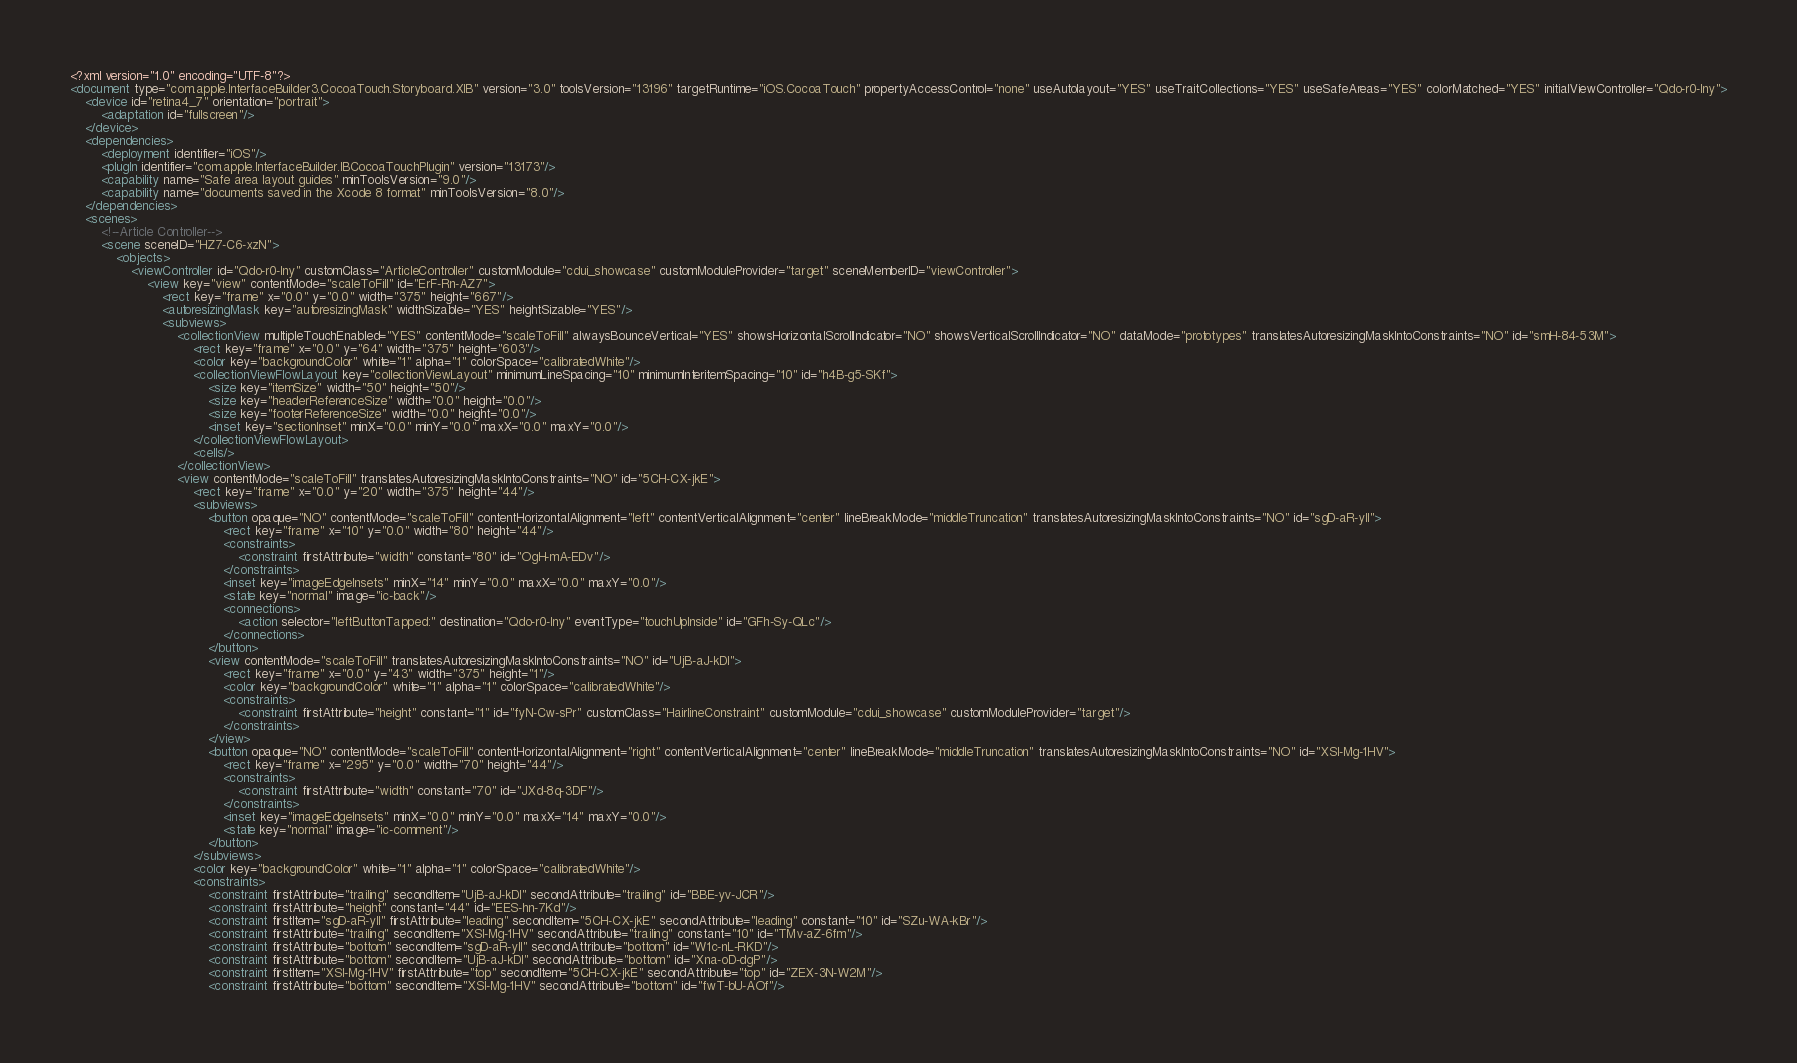Convert code to text. <code><loc_0><loc_0><loc_500><loc_500><_XML_><?xml version="1.0" encoding="UTF-8"?>
<document type="com.apple.InterfaceBuilder3.CocoaTouch.Storyboard.XIB" version="3.0" toolsVersion="13196" targetRuntime="iOS.CocoaTouch" propertyAccessControl="none" useAutolayout="YES" useTraitCollections="YES" useSafeAreas="YES" colorMatched="YES" initialViewController="Qdo-r0-Iny">
    <device id="retina4_7" orientation="portrait">
        <adaptation id="fullscreen"/>
    </device>
    <dependencies>
        <deployment identifier="iOS"/>
        <plugIn identifier="com.apple.InterfaceBuilder.IBCocoaTouchPlugin" version="13173"/>
        <capability name="Safe area layout guides" minToolsVersion="9.0"/>
        <capability name="documents saved in the Xcode 8 format" minToolsVersion="8.0"/>
    </dependencies>
    <scenes>
        <!--Article Controller-->
        <scene sceneID="HZ7-C6-xzN">
            <objects>
                <viewController id="Qdo-r0-Iny" customClass="ArticleController" customModule="cdui_showcase" customModuleProvider="target" sceneMemberID="viewController">
                    <view key="view" contentMode="scaleToFill" id="ErF-Rn-AZ7">
                        <rect key="frame" x="0.0" y="0.0" width="375" height="667"/>
                        <autoresizingMask key="autoresizingMask" widthSizable="YES" heightSizable="YES"/>
                        <subviews>
                            <collectionView multipleTouchEnabled="YES" contentMode="scaleToFill" alwaysBounceVertical="YES" showsHorizontalScrollIndicator="NO" showsVerticalScrollIndicator="NO" dataMode="prototypes" translatesAutoresizingMaskIntoConstraints="NO" id="smH-84-53M">
                                <rect key="frame" x="0.0" y="64" width="375" height="603"/>
                                <color key="backgroundColor" white="1" alpha="1" colorSpace="calibratedWhite"/>
                                <collectionViewFlowLayout key="collectionViewLayout" minimumLineSpacing="10" minimumInteritemSpacing="10" id="h4B-g5-SKf">
                                    <size key="itemSize" width="50" height="50"/>
                                    <size key="headerReferenceSize" width="0.0" height="0.0"/>
                                    <size key="footerReferenceSize" width="0.0" height="0.0"/>
                                    <inset key="sectionInset" minX="0.0" minY="0.0" maxX="0.0" maxY="0.0"/>
                                </collectionViewFlowLayout>
                                <cells/>
                            </collectionView>
                            <view contentMode="scaleToFill" translatesAutoresizingMaskIntoConstraints="NO" id="5CH-CX-jkE">
                                <rect key="frame" x="0.0" y="20" width="375" height="44"/>
                                <subviews>
                                    <button opaque="NO" contentMode="scaleToFill" contentHorizontalAlignment="left" contentVerticalAlignment="center" lineBreakMode="middleTruncation" translatesAutoresizingMaskIntoConstraints="NO" id="sgD-aR-yll">
                                        <rect key="frame" x="10" y="0.0" width="80" height="44"/>
                                        <constraints>
                                            <constraint firstAttribute="width" constant="80" id="OgH-mA-EDv"/>
                                        </constraints>
                                        <inset key="imageEdgeInsets" minX="14" minY="0.0" maxX="0.0" maxY="0.0"/>
                                        <state key="normal" image="ic-back"/>
                                        <connections>
                                            <action selector="leftButtonTapped:" destination="Qdo-r0-Iny" eventType="touchUpInside" id="GFh-Sy-QLc"/>
                                        </connections>
                                    </button>
                                    <view contentMode="scaleToFill" translatesAutoresizingMaskIntoConstraints="NO" id="UjB-aJ-kDI">
                                        <rect key="frame" x="0.0" y="43" width="375" height="1"/>
                                        <color key="backgroundColor" white="1" alpha="1" colorSpace="calibratedWhite"/>
                                        <constraints>
                                            <constraint firstAttribute="height" constant="1" id="fyN-Cw-sPr" customClass="HairlineConstraint" customModule="cdui_showcase" customModuleProvider="target"/>
                                        </constraints>
                                    </view>
                                    <button opaque="NO" contentMode="scaleToFill" contentHorizontalAlignment="right" contentVerticalAlignment="center" lineBreakMode="middleTruncation" translatesAutoresizingMaskIntoConstraints="NO" id="XSl-Mg-1HV">
                                        <rect key="frame" x="295" y="0.0" width="70" height="44"/>
                                        <constraints>
                                            <constraint firstAttribute="width" constant="70" id="JXd-8q-3DF"/>
                                        </constraints>
                                        <inset key="imageEdgeInsets" minX="0.0" minY="0.0" maxX="14" maxY="0.0"/>
                                        <state key="normal" image="ic-comment"/>
                                    </button>
                                </subviews>
                                <color key="backgroundColor" white="1" alpha="1" colorSpace="calibratedWhite"/>
                                <constraints>
                                    <constraint firstAttribute="trailing" secondItem="UjB-aJ-kDI" secondAttribute="trailing" id="BBE-yv-JCR"/>
                                    <constraint firstAttribute="height" constant="44" id="EES-hn-7Kd"/>
                                    <constraint firstItem="sgD-aR-yll" firstAttribute="leading" secondItem="5CH-CX-jkE" secondAttribute="leading" constant="10" id="SZu-WA-kBr"/>
                                    <constraint firstAttribute="trailing" secondItem="XSl-Mg-1HV" secondAttribute="trailing" constant="10" id="TMv-aZ-6fm"/>
                                    <constraint firstAttribute="bottom" secondItem="sgD-aR-yll" secondAttribute="bottom" id="W1c-nL-RKD"/>
                                    <constraint firstAttribute="bottom" secondItem="UjB-aJ-kDI" secondAttribute="bottom" id="Xna-oD-dgP"/>
                                    <constraint firstItem="XSl-Mg-1HV" firstAttribute="top" secondItem="5CH-CX-jkE" secondAttribute="top" id="ZEX-3N-W2M"/>
                                    <constraint firstAttribute="bottom" secondItem="XSl-Mg-1HV" secondAttribute="bottom" id="fwT-bU-AOf"/></code> 